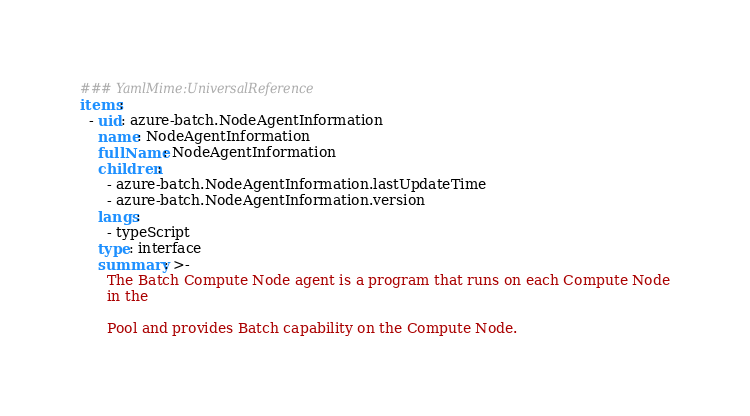<code> <loc_0><loc_0><loc_500><loc_500><_YAML_>### YamlMime:UniversalReference
items:
  - uid: azure-batch.NodeAgentInformation
    name: NodeAgentInformation
    fullName: NodeAgentInformation
    children:
      - azure-batch.NodeAgentInformation.lastUpdateTime
      - azure-batch.NodeAgentInformation.version
    langs:
      - typeScript
    type: interface
    summary: >-
      The Batch Compute Node agent is a program that runs on each Compute Node
      in the

      Pool and provides Batch capability on the Compute Node.</code> 